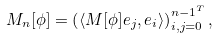Convert formula to latex. <formula><loc_0><loc_0><loc_500><loc_500>M _ { n } [ \phi ] = \left ( \langle M [ \phi ] e _ { j } , e _ { i } \rangle \right ) _ { i , j = 0 } ^ { n - { 1 } ^ { T } } ,</formula> 